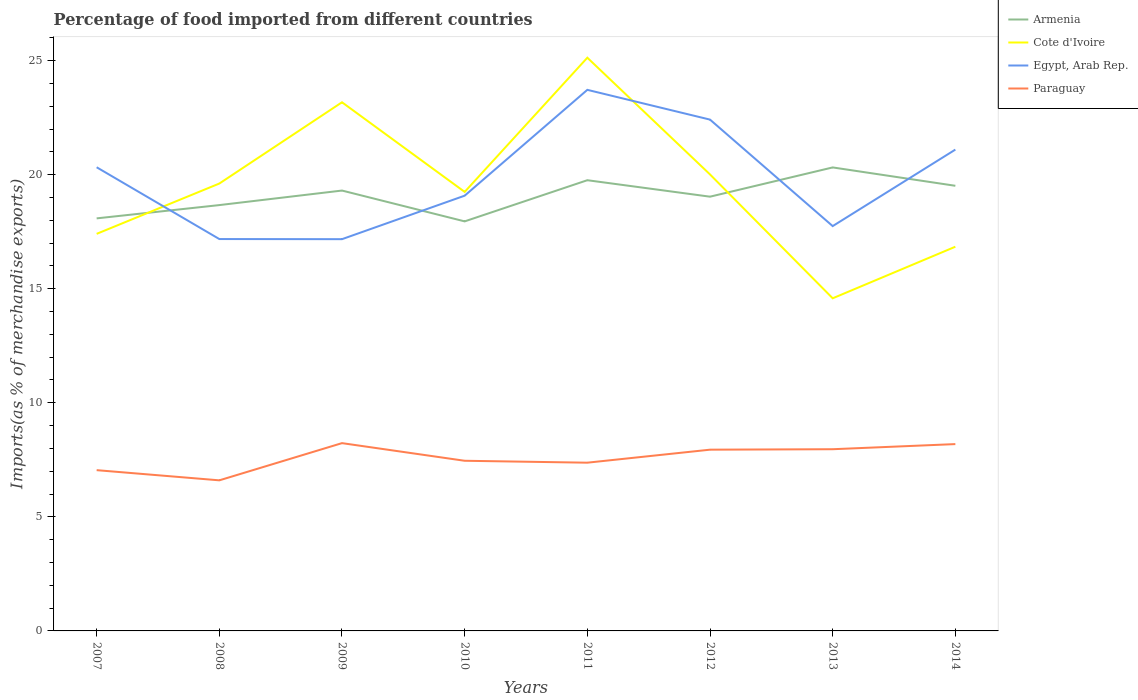Does the line corresponding to Paraguay intersect with the line corresponding to Egypt, Arab Rep.?
Your response must be concise. No. Is the number of lines equal to the number of legend labels?
Your answer should be compact. Yes. Across all years, what is the maximum percentage of imports to different countries in Cote d'Ivoire?
Your answer should be compact. 14.58. What is the total percentage of imports to different countries in Cote d'Ivoire in the graph?
Make the answer very short. 3.16. What is the difference between the highest and the second highest percentage of imports to different countries in Cote d'Ivoire?
Give a very brief answer. 10.55. How many years are there in the graph?
Your answer should be very brief. 8. Does the graph contain any zero values?
Ensure brevity in your answer.  No. Does the graph contain grids?
Provide a short and direct response. No. Where does the legend appear in the graph?
Your response must be concise. Top right. How are the legend labels stacked?
Offer a very short reply. Vertical. What is the title of the graph?
Ensure brevity in your answer.  Percentage of food imported from different countries. Does "Kosovo" appear as one of the legend labels in the graph?
Your answer should be very brief. No. What is the label or title of the X-axis?
Provide a succinct answer. Years. What is the label or title of the Y-axis?
Offer a very short reply. Imports(as % of merchandise exports). What is the Imports(as % of merchandise exports) in Armenia in 2007?
Your response must be concise. 18.08. What is the Imports(as % of merchandise exports) of Cote d'Ivoire in 2007?
Ensure brevity in your answer.  17.41. What is the Imports(as % of merchandise exports) in Egypt, Arab Rep. in 2007?
Your answer should be compact. 20.32. What is the Imports(as % of merchandise exports) of Paraguay in 2007?
Your answer should be compact. 7.05. What is the Imports(as % of merchandise exports) in Armenia in 2008?
Offer a very short reply. 18.67. What is the Imports(as % of merchandise exports) in Cote d'Ivoire in 2008?
Offer a very short reply. 19.61. What is the Imports(as % of merchandise exports) in Egypt, Arab Rep. in 2008?
Give a very brief answer. 17.18. What is the Imports(as % of merchandise exports) in Paraguay in 2008?
Your answer should be compact. 6.6. What is the Imports(as % of merchandise exports) of Armenia in 2009?
Give a very brief answer. 19.3. What is the Imports(as % of merchandise exports) in Cote d'Ivoire in 2009?
Provide a succinct answer. 23.17. What is the Imports(as % of merchandise exports) in Egypt, Arab Rep. in 2009?
Your answer should be compact. 17.17. What is the Imports(as % of merchandise exports) in Paraguay in 2009?
Ensure brevity in your answer.  8.23. What is the Imports(as % of merchandise exports) of Armenia in 2010?
Provide a short and direct response. 17.95. What is the Imports(as % of merchandise exports) in Cote d'Ivoire in 2010?
Ensure brevity in your answer.  19.24. What is the Imports(as % of merchandise exports) in Egypt, Arab Rep. in 2010?
Your answer should be very brief. 19.08. What is the Imports(as % of merchandise exports) in Paraguay in 2010?
Your answer should be compact. 7.46. What is the Imports(as % of merchandise exports) of Armenia in 2011?
Provide a short and direct response. 19.76. What is the Imports(as % of merchandise exports) of Cote d'Ivoire in 2011?
Provide a succinct answer. 25.13. What is the Imports(as % of merchandise exports) in Egypt, Arab Rep. in 2011?
Keep it short and to the point. 23.72. What is the Imports(as % of merchandise exports) of Paraguay in 2011?
Give a very brief answer. 7.37. What is the Imports(as % of merchandise exports) of Armenia in 2012?
Keep it short and to the point. 19.04. What is the Imports(as % of merchandise exports) in Cote d'Ivoire in 2012?
Provide a short and direct response. 20.01. What is the Imports(as % of merchandise exports) of Egypt, Arab Rep. in 2012?
Your answer should be compact. 22.41. What is the Imports(as % of merchandise exports) in Paraguay in 2012?
Offer a very short reply. 7.94. What is the Imports(as % of merchandise exports) of Armenia in 2013?
Your answer should be compact. 20.32. What is the Imports(as % of merchandise exports) in Cote d'Ivoire in 2013?
Provide a short and direct response. 14.58. What is the Imports(as % of merchandise exports) of Egypt, Arab Rep. in 2013?
Ensure brevity in your answer.  17.75. What is the Imports(as % of merchandise exports) in Paraguay in 2013?
Your response must be concise. 7.97. What is the Imports(as % of merchandise exports) of Armenia in 2014?
Your answer should be very brief. 19.51. What is the Imports(as % of merchandise exports) in Cote d'Ivoire in 2014?
Offer a terse response. 16.84. What is the Imports(as % of merchandise exports) in Egypt, Arab Rep. in 2014?
Ensure brevity in your answer.  21.1. What is the Imports(as % of merchandise exports) in Paraguay in 2014?
Provide a succinct answer. 8.19. Across all years, what is the maximum Imports(as % of merchandise exports) in Armenia?
Provide a short and direct response. 20.32. Across all years, what is the maximum Imports(as % of merchandise exports) of Cote d'Ivoire?
Give a very brief answer. 25.13. Across all years, what is the maximum Imports(as % of merchandise exports) of Egypt, Arab Rep.?
Offer a terse response. 23.72. Across all years, what is the maximum Imports(as % of merchandise exports) in Paraguay?
Give a very brief answer. 8.23. Across all years, what is the minimum Imports(as % of merchandise exports) of Armenia?
Offer a very short reply. 17.95. Across all years, what is the minimum Imports(as % of merchandise exports) in Cote d'Ivoire?
Give a very brief answer. 14.58. Across all years, what is the minimum Imports(as % of merchandise exports) of Egypt, Arab Rep.?
Provide a short and direct response. 17.17. Across all years, what is the minimum Imports(as % of merchandise exports) of Paraguay?
Provide a short and direct response. 6.6. What is the total Imports(as % of merchandise exports) of Armenia in the graph?
Provide a succinct answer. 152.63. What is the total Imports(as % of merchandise exports) in Cote d'Ivoire in the graph?
Your answer should be very brief. 156. What is the total Imports(as % of merchandise exports) in Egypt, Arab Rep. in the graph?
Offer a terse response. 158.73. What is the total Imports(as % of merchandise exports) of Paraguay in the graph?
Make the answer very short. 60.81. What is the difference between the Imports(as % of merchandise exports) in Armenia in 2007 and that in 2008?
Your response must be concise. -0.58. What is the difference between the Imports(as % of merchandise exports) of Cote d'Ivoire in 2007 and that in 2008?
Make the answer very short. -2.21. What is the difference between the Imports(as % of merchandise exports) of Egypt, Arab Rep. in 2007 and that in 2008?
Provide a succinct answer. 3.15. What is the difference between the Imports(as % of merchandise exports) in Paraguay in 2007 and that in 2008?
Offer a very short reply. 0.45. What is the difference between the Imports(as % of merchandise exports) in Armenia in 2007 and that in 2009?
Make the answer very short. -1.22. What is the difference between the Imports(as % of merchandise exports) of Cote d'Ivoire in 2007 and that in 2009?
Make the answer very short. -5.77. What is the difference between the Imports(as % of merchandise exports) of Egypt, Arab Rep. in 2007 and that in 2009?
Make the answer very short. 3.15. What is the difference between the Imports(as % of merchandise exports) in Paraguay in 2007 and that in 2009?
Provide a short and direct response. -1.18. What is the difference between the Imports(as % of merchandise exports) of Armenia in 2007 and that in 2010?
Keep it short and to the point. 0.13. What is the difference between the Imports(as % of merchandise exports) in Cote d'Ivoire in 2007 and that in 2010?
Offer a terse response. -1.84. What is the difference between the Imports(as % of merchandise exports) of Egypt, Arab Rep. in 2007 and that in 2010?
Make the answer very short. 1.25. What is the difference between the Imports(as % of merchandise exports) of Paraguay in 2007 and that in 2010?
Provide a succinct answer. -0.41. What is the difference between the Imports(as % of merchandise exports) of Armenia in 2007 and that in 2011?
Your response must be concise. -1.67. What is the difference between the Imports(as % of merchandise exports) in Cote d'Ivoire in 2007 and that in 2011?
Your response must be concise. -7.72. What is the difference between the Imports(as % of merchandise exports) of Egypt, Arab Rep. in 2007 and that in 2011?
Keep it short and to the point. -3.39. What is the difference between the Imports(as % of merchandise exports) of Paraguay in 2007 and that in 2011?
Give a very brief answer. -0.33. What is the difference between the Imports(as % of merchandise exports) in Armenia in 2007 and that in 2012?
Your response must be concise. -0.95. What is the difference between the Imports(as % of merchandise exports) of Cote d'Ivoire in 2007 and that in 2012?
Give a very brief answer. -2.6. What is the difference between the Imports(as % of merchandise exports) in Egypt, Arab Rep. in 2007 and that in 2012?
Provide a short and direct response. -2.09. What is the difference between the Imports(as % of merchandise exports) in Paraguay in 2007 and that in 2012?
Give a very brief answer. -0.9. What is the difference between the Imports(as % of merchandise exports) in Armenia in 2007 and that in 2013?
Your answer should be very brief. -2.23. What is the difference between the Imports(as % of merchandise exports) of Cote d'Ivoire in 2007 and that in 2013?
Your answer should be compact. 2.82. What is the difference between the Imports(as % of merchandise exports) in Egypt, Arab Rep. in 2007 and that in 2013?
Provide a short and direct response. 2.58. What is the difference between the Imports(as % of merchandise exports) of Paraguay in 2007 and that in 2013?
Offer a terse response. -0.92. What is the difference between the Imports(as % of merchandise exports) of Armenia in 2007 and that in 2014?
Your response must be concise. -1.43. What is the difference between the Imports(as % of merchandise exports) in Cote d'Ivoire in 2007 and that in 2014?
Your answer should be compact. 0.56. What is the difference between the Imports(as % of merchandise exports) of Egypt, Arab Rep. in 2007 and that in 2014?
Give a very brief answer. -0.77. What is the difference between the Imports(as % of merchandise exports) of Paraguay in 2007 and that in 2014?
Offer a very short reply. -1.14. What is the difference between the Imports(as % of merchandise exports) of Armenia in 2008 and that in 2009?
Offer a very short reply. -0.64. What is the difference between the Imports(as % of merchandise exports) of Cote d'Ivoire in 2008 and that in 2009?
Offer a very short reply. -3.56. What is the difference between the Imports(as % of merchandise exports) of Egypt, Arab Rep. in 2008 and that in 2009?
Offer a very short reply. 0.01. What is the difference between the Imports(as % of merchandise exports) in Paraguay in 2008 and that in 2009?
Make the answer very short. -1.63. What is the difference between the Imports(as % of merchandise exports) in Armenia in 2008 and that in 2010?
Keep it short and to the point. 0.71. What is the difference between the Imports(as % of merchandise exports) of Cote d'Ivoire in 2008 and that in 2010?
Offer a terse response. 0.37. What is the difference between the Imports(as % of merchandise exports) in Egypt, Arab Rep. in 2008 and that in 2010?
Provide a succinct answer. -1.9. What is the difference between the Imports(as % of merchandise exports) in Paraguay in 2008 and that in 2010?
Offer a terse response. -0.86. What is the difference between the Imports(as % of merchandise exports) of Armenia in 2008 and that in 2011?
Ensure brevity in your answer.  -1.09. What is the difference between the Imports(as % of merchandise exports) in Cote d'Ivoire in 2008 and that in 2011?
Your answer should be very brief. -5.52. What is the difference between the Imports(as % of merchandise exports) in Egypt, Arab Rep. in 2008 and that in 2011?
Provide a succinct answer. -6.54. What is the difference between the Imports(as % of merchandise exports) in Paraguay in 2008 and that in 2011?
Provide a succinct answer. -0.77. What is the difference between the Imports(as % of merchandise exports) in Armenia in 2008 and that in 2012?
Ensure brevity in your answer.  -0.37. What is the difference between the Imports(as % of merchandise exports) of Cote d'Ivoire in 2008 and that in 2012?
Offer a terse response. -0.4. What is the difference between the Imports(as % of merchandise exports) in Egypt, Arab Rep. in 2008 and that in 2012?
Make the answer very short. -5.24. What is the difference between the Imports(as % of merchandise exports) of Paraguay in 2008 and that in 2012?
Provide a succinct answer. -1.34. What is the difference between the Imports(as % of merchandise exports) of Armenia in 2008 and that in 2013?
Offer a terse response. -1.65. What is the difference between the Imports(as % of merchandise exports) of Cote d'Ivoire in 2008 and that in 2013?
Keep it short and to the point. 5.03. What is the difference between the Imports(as % of merchandise exports) in Egypt, Arab Rep. in 2008 and that in 2013?
Your answer should be compact. -0.57. What is the difference between the Imports(as % of merchandise exports) in Paraguay in 2008 and that in 2013?
Give a very brief answer. -1.36. What is the difference between the Imports(as % of merchandise exports) in Armenia in 2008 and that in 2014?
Keep it short and to the point. -0.85. What is the difference between the Imports(as % of merchandise exports) of Cote d'Ivoire in 2008 and that in 2014?
Ensure brevity in your answer.  2.77. What is the difference between the Imports(as % of merchandise exports) in Egypt, Arab Rep. in 2008 and that in 2014?
Make the answer very short. -3.92. What is the difference between the Imports(as % of merchandise exports) of Paraguay in 2008 and that in 2014?
Your answer should be very brief. -1.59. What is the difference between the Imports(as % of merchandise exports) of Armenia in 2009 and that in 2010?
Provide a succinct answer. 1.35. What is the difference between the Imports(as % of merchandise exports) of Cote d'Ivoire in 2009 and that in 2010?
Offer a terse response. 3.93. What is the difference between the Imports(as % of merchandise exports) in Egypt, Arab Rep. in 2009 and that in 2010?
Your answer should be very brief. -1.91. What is the difference between the Imports(as % of merchandise exports) in Paraguay in 2009 and that in 2010?
Your answer should be very brief. 0.77. What is the difference between the Imports(as % of merchandise exports) in Armenia in 2009 and that in 2011?
Your answer should be compact. -0.45. What is the difference between the Imports(as % of merchandise exports) in Cote d'Ivoire in 2009 and that in 2011?
Offer a very short reply. -1.95. What is the difference between the Imports(as % of merchandise exports) in Egypt, Arab Rep. in 2009 and that in 2011?
Give a very brief answer. -6.55. What is the difference between the Imports(as % of merchandise exports) of Paraguay in 2009 and that in 2011?
Keep it short and to the point. 0.86. What is the difference between the Imports(as % of merchandise exports) of Armenia in 2009 and that in 2012?
Your answer should be compact. 0.27. What is the difference between the Imports(as % of merchandise exports) in Cote d'Ivoire in 2009 and that in 2012?
Ensure brevity in your answer.  3.16. What is the difference between the Imports(as % of merchandise exports) of Egypt, Arab Rep. in 2009 and that in 2012?
Your response must be concise. -5.24. What is the difference between the Imports(as % of merchandise exports) in Paraguay in 2009 and that in 2012?
Give a very brief answer. 0.29. What is the difference between the Imports(as % of merchandise exports) in Armenia in 2009 and that in 2013?
Give a very brief answer. -1.01. What is the difference between the Imports(as % of merchandise exports) of Cote d'Ivoire in 2009 and that in 2013?
Your answer should be compact. 8.59. What is the difference between the Imports(as % of merchandise exports) of Egypt, Arab Rep. in 2009 and that in 2013?
Make the answer very short. -0.57. What is the difference between the Imports(as % of merchandise exports) in Paraguay in 2009 and that in 2013?
Provide a succinct answer. 0.27. What is the difference between the Imports(as % of merchandise exports) in Armenia in 2009 and that in 2014?
Keep it short and to the point. -0.21. What is the difference between the Imports(as % of merchandise exports) in Cote d'Ivoire in 2009 and that in 2014?
Provide a succinct answer. 6.33. What is the difference between the Imports(as % of merchandise exports) of Egypt, Arab Rep. in 2009 and that in 2014?
Provide a succinct answer. -3.93. What is the difference between the Imports(as % of merchandise exports) in Paraguay in 2009 and that in 2014?
Your answer should be very brief. 0.04. What is the difference between the Imports(as % of merchandise exports) in Armenia in 2010 and that in 2011?
Provide a short and direct response. -1.8. What is the difference between the Imports(as % of merchandise exports) in Cote d'Ivoire in 2010 and that in 2011?
Provide a short and direct response. -5.88. What is the difference between the Imports(as % of merchandise exports) in Egypt, Arab Rep. in 2010 and that in 2011?
Provide a succinct answer. -4.64. What is the difference between the Imports(as % of merchandise exports) in Paraguay in 2010 and that in 2011?
Make the answer very short. 0.08. What is the difference between the Imports(as % of merchandise exports) of Armenia in 2010 and that in 2012?
Provide a succinct answer. -1.08. What is the difference between the Imports(as % of merchandise exports) in Cote d'Ivoire in 2010 and that in 2012?
Your answer should be compact. -0.77. What is the difference between the Imports(as % of merchandise exports) in Egypt, Arab Rep. in 2010 and that in 2012?
Keep it short and to the point. -3.33. What is the difference between the Imports(as % of merchandise exports) in Paraguay in 2010 and that in 2012?
Make the answer very short. -0.49. What is the difference between the Imports(as % of merchandise exports) in Armenia in 2010 and that in 2013?
Ensure brevity in your answer.  -2.36. What is the difference between the Imports(as % of merchandise exports) in Cote d'Ivoire in 2010 and that in 2013?
Your response must be concise. 4.66. What is the difference between the Imports(as % of merchandise exports) of Egypt, Arab Rep. in 2010 and that in 2013?
Your answer should be compact. 1.33. What is the difference between the Imports(as % of merchandise exports) of Paraguay in 2010 and that in 2013?
Give a very brief answer. -0.51. What is the difference between the Imports(as % of merchandise exports) of Armenia in 2010 and that in 2014?
Provide a succinct answer. -1.56. What is the difference between the Imports(as % of merchandise exports) in Cote d'Ivoire in 2010 and that in 2014?
Keep it short and to the point. 2.4. What is the difference between the Imports(as % of merchandise exports) of Egypt, Arab Rep. in 2010 and that in 2014?
Give a very brief answer. -2.02. What is the difference between the Imports(as % of merchandise exports) of Paraguay in 2010 and that in 2014?
Provide a short and direct response. -0.73. What is the difference between the Imports(as % of merchandise exports) of Armenia in 2011 and that in 2012?
Your response must be concise. 0.72. What is the difference between the Imports(as % of merchandise exports) of Cote d'Ivoire in 2011 and that in 2012?
Offer a very short reply. 5.12. What is the difference between the Imports(as % of merchandise exports) of Egypt, Arab Rep. in 2011 and that in 2012?
Provide a short and direct response. 1.3. What is the difference between the Imports(as % of merchandise exports) of Paraguay in 2011 and that in 2012?
Keep it short and to the point. -0.57. What is the difference between the Imports(as % of merchandise exports) in Armenia in 2011 and that in 2013?
Offer a very short reply. -0.56. What is the difference between the Imports(as % of merchandise exports) in Cote d'Ivoire in 2011 and that in 2013?
Ensure brevity in your answer.  10.55. What is the difference between the Imports(as % of merchandise exports) in Egypt, Arab Rep. in 2011 and that in 2013?
Keep it short and to the point. 5.97. What is the difference between the Imports(as % of merchandise exports) of Paraguay in 2011 and that in 2013?
Give a very brief answer. -0.59. What is the difference between the Imports(as % of merchandise exports) of Armenia in 2011 and that in 2014?
Offer a very short reply. 0.24. What is the difference between the Imports(as % of merchandise exports) in Cote d'Ivoire in 2011 and that in 2014?
Provide a succinct answer. 8.29. What is the difference between the Imports(as % of merchandise exports) in Egypt, Arab Rep. in 2011 and that in 2014?
Your answer should be very brief. 2.62. What is the difference between the Imports(as % of merchandise exports) of Paraguay in 2011 and that in 2014?
Your answer should be very brief. -0.81. What is the difference between the Imports(as % of merchandise exports) in Armenia in 2012 and that in 2013?
Your answer should be compact. -1.28. What is the difference between the Imports(as % of merchandise exports) of Cote d'Ivoire in 2012 and that in 2013?
Keep it short and to the point. 5.43. What is the difference between the Imports(as % of merchandise exports) in Egypt, Arab Rep. in 2012 and that in 2013?
Your answer should be compact. 4.67. What is the difference between the Imports(as % of merchandise exports) in Paraguay in 2012 and that in 2013?
Your answer should be compact. -0.02. What is the difference between the Imports(as % of merchandise exports) of Armenia in 2012 and that in 2014?
Your answer should be very brief. -0.48. What is the difference between the Imports(as % of merchandise exports) of Cote d'Ivoire in 2012 and that in 2014?
Make the answer very short. 3.17. What is the difference between the Imports(as % of merchandise exports) in Egypt, Arab Rep. in 2012 and that in 2014?
Provide a short and direct response. 1.31. What is the difference between the Imports(as % of merchandise exports) of Paraguay in 2012 and that in 2014?
Offer a very short reply. -0.24. What is the difference between the Imports(as % of merchandise exports) in Armenia in 2013 and that in 2014?
Your response must be concise. 0.8. What is the difference between the Imports(as % of merchandise exports) of Cote d'Ivoire in 2013 and that in 2014?
Your answer should be compact. -2.26. What is the difference between the Imports(as % of merchandise exports) of Egypt, Arab Rep. in 2013 and that in 2014?
Provide a short and direct response. -3.35. What is the difference between the Imports(as % of merchandise exports) of Paraguay in 2013 and that in 2014?
Make the answer very short. -0.22. What is the difference between the Imports(as % of merchandise exports) in Armenia in 2007 and the Imports(as % of merchandise exports) in Cote d'Ivoire in 2008?
Offer a very short reply. -1.53. What is the difference between the Imports(as % of merchandise exports) of Armenia in 2007 and the Imports(as % of merchandise exports) of Egypt, Arab Rep. in 2008?
Offer a very short reply. 0.91. What is the difference between the Imports(as % of merchandise exports) of Armenia in 2007 and the Imports(as % of merchandise exports) of Paraguay in 2008?
Your answer should be compact. 11.48. What is the difference between the Imports(as % of merchandise exports) in Cote d'Ivoire in 2007 and the Imports(as % of merchandise exports) in Egypt, Arab Rep. in 2008?
Make the answer very short. 0.23. What is the difference between the Imports(as % of merchandise exports) of Cote d'Ivoire in 2007 and the Imports(as % of merchandise exports) of Paraguay in 2008?
Keep it short and to the point. 10.8. What is the difference between the Imports(as % of merchandise exports) of Egypt, Arab Rep. in 2007 and the Imports(as % of merchandise exports) of Paraguay in 2008?
Your answer should be compact. 13.72. What is the difference between the Imports(as % of merchandise exports) in Armenia in 2007 and the Imports(as % of merchandise exports) in Cote d'Ivoire in 2009?
Your response must be concise. -5.09. What is the difference between the Imports(as % of merchandise exports) in Armenia in 2007 and the Imports(as % of merchandise exports) in Egypt, Arab Rep. in 2009?
Provide a succinct answer. 0.91. What is the difference between the Imports(as % of merchandise exports) in Armenia in 2007 and the Imports(as % of merchandise exports) in Paraguay in 2009?
Provide a short and direct response. 9.85. What is the difference between the Imports(as % of merchandise exports) of Cote d'Ivoire in 2007 and the Imports(as % of merchandise exports) of Egypt, Arab Rep. in 2009?
Ensure brevity in your answer.  0.23. What is the difference between the Imports(as % of merchandise exports) of Cote d'Ivoire in 2007 and the Imports(as % of merchandise exports) of Paraguay in 2009?
Make the answer very short. 9.17. What is the difference between the Imports(as % of merchandise exports) in Egypt, Arab Rep. in 2007 and the Imports(as % of merchandise exports) in Paraguay in 2009?
Keep it short and to the point. 12.09. What is the difference between the Imports(as % of merchandise exports) of Armenia in 2007 and the Imports(as % of merchandise exports) of Cote d'Ivoire in 2010?
Provide a succinct answer. -1.16. What is the difference between the Imports(as % of merchandise exports) of Armenia in 2007 and the Imports(as % of merchandise exports) of Egypt, Arab Rep. in 2010?
Ensure brevity in your answer.  -0.99. What is the difference between the Imports(as % of merchandise exports) of Armenia in 2007 and the Imports(as % of merchandise exports) of Paraguay in 2010?
Offer a very short reply. 10.63. What is the difference between the Imports(as % of merchandise exports) of Cote d'Ivoire in 2007 and the Imports(as % of merchandise exports) of Egypt, Arab Rep. in 2010?
Provide a succinct answer. -1.67. What is the difference between the Imports(as % of merchandise exports) in Cote d'Ivoire in 2007 and the Imports(as % of merchandise exports) in Paraguay in 2010?
Give a very brief answer. 9.95. What is the difference between the Imports(as % of merchandise exports) of Egypt, Arab Rep. in 2007 and the Imports(as % of merchandise exports) of Paraguay in 2010?
Offer a very short reply. 12.87. What is the difference between the Imports(as % of merchandise exports) in Armenia in 2007 and the Imports(as % of merchandise exports) in Cote d'Ivoire in 2011?
Give a very brief answer. -7.04. What is the difference between the Imports(as % of merchandise exports) in Armenia in 2007 and the Imports(as % of merchandise exports) in Egypt, Arab Rep. in 2011?
Offer a very short reply. -5.63. What is the difference between the Imports(as % of merchandise exports) of Armenia in 2007 and the Imports(as % of merchandise exports) of Paraguay in 2011?
Offer a very short reply. 10.71. What is the difference between the Imports(as % of merchandise exports) of Cote d'Ivoire in 2007 and the Imports(as % of merchandise exports) of Egypt, Arab Rep. in 2011?
Your answer should be very brief. -6.31. What is the difference between the Imports(as % of merchandise exports) of Cote d'Ivoire in 2007 and the Imports(as % of merchandise exports) of Paraguay in 2011?
Your answer should be very brief. 10.03. What is the difference between the Imports(as % of merchandise exports) in Egypt, Arab Rep. in 2007 and the Imports(as % of merchandise exports) in Paraguay in 2011?
Your response must be concise. 12.95. What is the difference between the Imports(as % of merchandise exports) in Armenia in 2007 and the Imports(as % of merchandise exports) in Cote d'Ivoire in 2012?
Provide a succinct answer. -1.93. What is the difference between the Imports(as % of merchandise exports) in Armenia in 2007 and the Imports(as % of merchandise exports) in Egypt, Arab Rep. in 2012?
Give a very brief answer. -4.33. What is the difference between the Imports(as % of merchandise exports) in Armenia in 2007 and the Imports(as % of merchandise exports) in Paraguay in 2012?
Your answer should be very brief. 10.14. What is the difference between the Imports(as % of merchandise exports) of Cote d'Ivoire in 2007 and the Imports(as % of merchandise exports) of Egypt, Arab Rep. in 2012?
Your answer should be compact. -5.01. What is the difference between the Imports(as % of merchandise exports) in Cote d'Ivoire in 2007 and the Imports(as % of merchandise exports) in Paraguay in 2012?
Give a very brief answer. 9.46. What is the difference between the Imports(as % of merchandise exports) of Egypt, Arab Rep. in 2007 and the Imports(as % of merchandise exports) of Paraguay in 2012?
Provide a succinct answer. 12.38. What is the difference between the Imports(as % of merchandise exports) of Armenia in 2007 and the Imports(as % of merchandise exports) of Cote d'Ivoire in 2013?
Offer a very short reply. 3.5. What is the difference between the Imports(as % of merchandise exports) in Armenia in 2007 and the Imports(as % of merchandise exports) in Egypt, Arab Rep. in 2013?
Offer a very short reply. 0.34. What is the difference between the Imports(as % of merchandise exports) in Armenia in 2007 and the Imports(as % of merchandise exports) in Paraguay in 2013?
Offer a very short reply. 10.12. What is the difference between the Imports(as % of merchandise exports) of Cote d'Ivoire in 2007 and the Imports(as % of merchandise exports) of Egypt, Arab Rep. in 2013?
Your answer should be very brief. -0.34. What is the difference between the Imports(as % of merchandise exports) of Cote d'Ivoire in 2007 and the Imports(as % of merchandise exports) of Paraguay in 2013?
Keep it short and to the point. 9.44. What is the difference between the Imports(as % of merchandise exports) in Egypt, Arab Rep. in 2007 and the Imports(as % of merchandise exports) in Paraguay in 2013?
Give a very brief answer. 12.36. What is the difference between the Imports(as % of merchandise exports) of Armenia in 2007 and the Imports(as % of merchandise exports) of Cote d'Ivoire in 2014?
Provide a succinct answer. 1.24. What is the difference between the Imports(as % of merchandise exports) in Armenia in 2007 and the Imports(as % of merchandise exports) in Egypt, Arab Rep. in 2014?
Offer a very short reply. -3.01. What is the difference between the Imports(as % of merchandise exports) of Armenia in 2007 and the Imports(as % of merchandise exports) of Paraguay in 2014?
Your response must be concise. 9.89. What is the difference between the Imports(as % of merchandise exports) of Cote d'Ivoire in 2007 and the Imports(as % of merchandise exports) of Egypt, Arab Rep. in 2014?
Your response must be concise. -3.69. What is the difference between the Imports(as % of merchandise exports) of Cote d'Ivoire in 2007 and the Imports(as % of merchandise exports) of Paraguay in 2014?
Offer a very short reply. 9.22. What is the difference between the Imports(as % of merchandise exports) of Egypt, Arab Rep. in 2007 and the Imports(as % of merchandise exports) of Paraguay in 2014?
Ensure brevity in your answer.  12.14. What is the difference between the Imports(as % of merchandise exports) of Armenia in 2008 and the Imports(as % of merchandise exports) of Cote d'Ivoire in 2009?
Provide a succinct answer. -4.51. What is the difference between the Imports(as % of merchandise exports) of Armenia in 2008 and the Imports(as % of merchandise exports) of Egypt, Arab Rep. in 2009?
Make the answer very short. 1.49. What is the difference between the Imports(as % of merchandise exports) in Armenia in 2008 and the Imports(as % of merchandise exports) in Paraguay in 2009?
Your answer should be very brief. 10.43. What is the difference between the Imports(as % of merchandise exports) of Cote d'Ivoire in 2008 and the Imports(as % of merchandise exports) of Egypt, Arab Rep. in 2009?
Provide a succinct answer. 2.44. What is the difference between the Imports(as % of merchandise exports) in Cote d'Ivoire in 2008 and the Imports(as % of merchandise exports) in Paraguay in 2009?
Your answer should be very brief. 11.38. What is the difference between the Imports(as % of merchandise exports) in Egypt, Arab Rep. in 2008 and the Imports(as % of merchandise exports) in Paraguay in 2009?
Your answer should be very brief. 8.95. What is the difference between the Imports(as % of merchandise exports) of Armenia in 2008 and the Imports(as % of merchandise exports) of Cote d'Ivoire in 2010?
Offer a very short reply. -0.58. What is the difference between the Imports(as % of merchandise exports) of Armenia in 2008 and the Imports(as % of merchandise exports) of Egypt, Arab Rep. in 2010?
Ensure brevity in your answer.  -0.41. What is the difference between the Imports(as % of merchandise exports) of Armenia in 2008 and the Imports(as % of merchandise exports) of Paraguay in 2010?
Provide a short and direct response. 11.21. What is the difference between the Imports(as % of merchandise exports) of Cote d'Ivoire in 2008 and the Imports(as % of merchandise exports) of Egypt, Arab Rep. in 2010?
Ensure brevity in your answer.  0.53. What is the difference between the Imports(as % of merchandise exports) of Cote d'Ivoire in 2008 and the Imports(as % of merchandise exports) of Paraguay in 2010?
Your answer should be very brief. 12.15. What is the difference between the Imports(as % of merchandise exports) of Egypt, Arab Rep. in 2008 and the Imports(as % of merchandise exports) of Paraguay in 2010?
Offer a terse response. 9.72. What is the difference between the Imports(as % of merchandise exports) in Armenia in 2008 and the Imports(as % of merchandise exports) in Cote d'Ivoire in 2011?
Ensure brevity in your answer.  -6.46. What is the difference between the Imports(as % of merchandise exports) of Armenia in 2008 and the Imports(as % of merchandise exports) of Egypt, Arab Rep. in 2011?
Make the answer very short. -5.05. What is the difference between the Imports(as % of merchandise exports) in Armenia in 2008 and the Imports(as % of merchandise exports) in Paraguay in 2011?
Offer a very short reply. 11.29. What is the difference between the Imports(as % of merchandise exports) of Cote d'Ivoire in 2008 and the Imports(as % of merchandise exports) of Egypt, Arab Rep. in 2011?
Offer a terse response. -4.11. What is the difference between the Imports(as % of merchandise exports) of Cote d'Ivoire in 2008 and the Imports(as % of merchandise exports) of Paraguay in 2011?
Your response must be concise. 12.24. What is the difference between the Imports(as % of merchandise exports) of Egypt, Arab Rep. in 2008 and the Imports(as % of merchandise exports) of Paraguay in 2011?
Ensure brevity in your answer.  9.8. What is the difference between the Imports(as % of merchandise exports) of Armenia in 2008 and the Imports(as % of merchandise exports) of Cote d'Ivoire in 2012?
Offer a terse response. -1.34. What is the difference between the Imports(as % of merchandise exports) of Armenia in 2008 and the Imports(as % of merchandise exports) of Egypt, Arab Rep. in 2012?
Keep it short and to the point. -3.75. What is the difference between the Imports(as % of merchandise exports) of Armenia in 2008 and the Imports(as % of merchandise exports) of Paraguay in 2012?
Keep it short and to the point. 10.72. What is the difference between the Imports(as % of merchandise exports) of Cote d'Ivoire in 2008 and the Imports(as % of merchandise exports) of Egypt, Arab Rep. in 2012?
Provide a succinct answer. -2.8. What is the difference between the Imports(as % of merchandise exports) of Cote d'Ivoire in 2008 and the Imports(as % of merchandise exports) of Paraguay in 2012?
Give a very brief answer. 11.67. What is the difference between the Imports(as % of merchandise exports) of Egypt, Arab Rep. in 2008 and the Imports(as % of merchandise exports) of Paraguay in 2012?
Provide a short and direct response. 9.23. What is the difference between the Imports(as % of merchandise exports) in Armenia in 2008 and the Imports(as % of merchandise exports) in Cote d'Ivoire in 2013?
Keep it short and to the point. 4.09. What is the difference between the Imports(as % of merchandise exports) of Armenia in 2008 and the Imports(as % of merchandise exports) of Egypt, Arab Rep. in 2013?
Your answer should be compact. 0.92. What is the difference between the Imports(as % of merchandise exports) in Armenia in 2008 and the Imports(as % of merchandise exports) in Paraguay in 2013?
Your answer should be very brief. 10.7. What is the difference between the Imports(as % of merchandise exports) of Cote d'Ivoire in 2008 and the Imports(as % of merchandise exports) of Egypt, Arab Rep. in 2013?
Keep it short and to the point. 1.87. What is the difference between the Imports(as % of merchandise exports) in Cote d'Ivoire in 2008 and the Imports(as % of merchandise exports) in Paraguay in 2013?
Give a very brief answer. 11.65. What is the difference between the Imports(as % of merchandise exports) of Egypt, Arab Rep. in 2008 and the Imports(as % of merchandise exports) of Paraguay in 2013?
Your response must be concise. 9.21. What is the difference between the Imports(as % of merchandise exports) of Armenia in 2008 and the Imports(as % of merchandise exports) of Cote d'Ivoire in 2014?
Make the answer very short. 1.82. What is the difference between the Imports(as % of merchandise exports) of Armenia in 2008 and the Imports(as % of merchandise exports) of Egypt, Arab Rep. in 2014?
Give a very brief answer. -2.43. What is the difference between the Imports(as % of merchandise exports) of Armenia in 2008 and the Imports(as % of merchandise exports) of Paraguay in 2014?
Offer a very short reply. 10.48. What is the difference between the Imports(as % of merchandise exports) of Cote d'Ivoire in 2008 and the Imports(as % of merchandise exports) of Egypt, Arab Rep. in 2014?
Make the answer very short. -1.49. What is the difference between the Imports(as % of merchandise exports) in Cote d'Ivoire in 2008 and the Imports(as % of merchandise exports) in Paraguay in 2014?
Provide a succinct answer. 11.42. What is the difference between the Imports(as % of merchandise exports) in Egypt, Arab Rep. in 2008 and the Imports(as % of merchandise exports) in Paraguay in 2014?
Ensure brevity in your answer.  8.99. What is the difference between the Imports(as % of merchandise exports) in Armenia in 2009 and the Imports(as % of merchandise exports) in Cote d'Ivoire in 2010?
Ensure brevity in your answer.  0.06. What is the difference between the Imports(as % of merchandise exports) in Armenia in 2009 and the Imports(as % of merchandise exports) in Egypt, Arab Rep. in 2010?
Give a very brief answer. 0.22. What is the difference between the Imports(as % of merchandise exports) in Armenia in 2009 and the Imports(as % of merchandise exports) in Paraguay in 2010?
Your response must be concise. 11.85. What is the difference between the Imports(as % of merchandise exports) of Cote d'Ivoire in 2009 and the Imports(as % of merchandise exports) of Egypt, Arab Rep. in 2010?
Your answer should be compact. 4.09. What is the difference between the Imports(as % of merchandise exports) of Cote d'Ivoire in 2009 and the Imports(as % of merchandise exports) of Paraguay in 2010?
Keep it short and to the point. 15.72. What is the difference between the Imports(as % of merchandise exports) in Egypt, Arab Rep. in 2009 and the Imports(as % of merchandise exports) in Paraguay in 2010?
Make the answer very short. 9.71. What is the difference between the Imports(as % of merchandise exports) in Armenia in 2009 and the Imports(as % of merchandise exports) in Cote d'Ivoire in 2011?
Provide a short and direct response. -5.82. What is the difference between the Imports(as % of merchandise exports) of Armenia in 2009 and the Imports(as % of merchandise exports) of Egypt, Arab Rep. in 2011?
Make the answer very short. -4.41. What is the difference between the Imports(as % of merchandise exports) in Armenia in 2009 and the Imports(as % of merchandise exports) in Paraguay in 2011?
Provide a short and direct response. 11.93. What is the difference between the Imports(as % of merchandise exports) of Cote d'Ivoire in 2009 and the Imports(as % of merchandise exports) of Egypt, Arab Rep. in 2011?
Provide a short and direct response. -0.54. What is the difference between the Imports(as % of merchandise exports) of Cote d'Ivoire in 2009 and the Imports(as % of merchandise exports) of Paraguay in 2011?
Ensure brevity in your answer.  15.8. What is the difference between the Imports(as % of merchandise exports) of Egypt, Arab Rep. in 2009 and the Imports(as % of merchandise exports) of Paraguay in 2011?
Give a very brief answer. 9.8. What is the difference between the Imports(as % of merchandise exports) in Armenia in 2009 and the Imports(as % of merchandise exports) in Cote d'Ivoire in 2012?
Keep it short and to the point. -0.71. What is the difference between the Imports(as % of merchandise exports) of Armenia in 2009 and the Imports(as % of merchandise exports) of Egypt, Arab Rep. in 2012?
Offer a very short reply. -3.11. What is the difference between the Imports(as % of merchandise exports) in Armenia in 2009 and the Imports(as % of merchandise exports) in Paraguay in 2012?
Your answer should be very brief. 11.36. What is the difference between the Imports(as % of merchandise exports) in Cote d'Ivoire in 2009 and the Imports(as % of merchandise exports) in Egypt, Arab Rep. in 2012?
Ensure brevity in your answer.  0.76. What is the difference between the Imports(as % of merchandise exports) of Cote d'Ivoire in 2009 and the Imports(as % of merchandise exports) of Paraguay in 2012?
Make the answer very short. 15.23. What is the difference between the Imports(as % of merchandise exports) in Egypt, Arab Rep. in 2009 and the Imports(as % of merchandise exports) in Paraguay in 2012?
Your answer should be compact. 9.23. What is the difference between the Imports(as % of merchandise exports) of Armenia in 2009 and the Imports(as % of merchandise exports) of Cote d'Ivoire in 2013?
Ensure brevity in your answer.  4.72. What is the difference between the Imports(as % of merchandise exports) in Armenia in 2009 and the Imports(as % of merchandise exports) in Egypt, Arab Rep. in 2013?
Keep it short and to the point. 1.56. What is the difference between the Imports(as % of merchandise exports) of Armenia in 2009 and the Imports(as % of merchandise exports) of Paraguay in 2013?
Provide a short and direct response. 11.34. What is the difference between the Imports(as % of merchandise exports) of Cote d'Ivoire in 2009 and the Imports(as % of merchandise exports) of Egypt, Arab Rep. in 2013?
Keep it short and to the point. 5.43. What is the difference between the Imports(as % of merchandise exports) of Cote d'Ivoire in 2009 and the Imports(as % of merchandise exports) of Paraguay in 2013?
Ensure brevity in your answer.  15.21. What is the difference between the Imports(as % of merchandise exports) in Egypt, Arab Rep. in 2009 and the Imports(as % of merchandise exports) in Paraguay in 2013?
Your answer should be very brief. 9.21. What is the difference between the Imports(as % of merchandise exports) of Armenia in 2009 and the Imports(as % of merchandise exports) of Cote d'Ivoire in 2014?
Your answer should be very brief. 2.46. What is the difference between the Imports(as % of merchandise exports) in Armenia in 2009 and the Imports(as % of merchandise exports) in Egypt, Arab Rep. in 2014?
Offer a terse response. -1.8. What is the difference between the Imports(as % of merchandise exports) of Armenia in 2009 and the Imports(as % of merchandise exports) of Paraguay in 2014?
Your response must be concise. 11.11. What is the difference between the Imports(as % of merchandise exports) in Cote d'Ivoire in 2009 and the Imports(as % of merchandise exports) in Egypt, Arab Rep. in 2014?
Provide a short and direct response. 2.07. What is the difference between the Imports(as % of merchandise exports) of Cote d'Ivoire in 2009 and the Imports(as % of merchandise exports) of Paraguay in 2014?
Your answer should be very brief. 14.98. What is the difference between the Imports(as % of merchandise exports) in Egypt, Arab Rep. in 2009 and the Imports(as % of merchandise exports) in Paraguay in 2014?
Make the answer very short. 8.98. What is the difference between the Imports(as % of merchandise exports) of Armenia in 2010 and the Imports(as % of merchandise exports) of Cote d'Ivoire in 2011?
Give a very brief answer. -7.17. What is the difference between the Imports(as % of merchandise exports) in Armenia in 2010 and the Imports(as % of merchandise exports) in Egypt, Arab Rep. in 2011?
Provide a short and direct response. -5.77. What is the difference between the Imports(as % of merchandise exports) of Armenia in 2010 and the Imports(as % of merchandise exports) of Paraguay in 2011?
Provide a short and direct response. 10.58. What is the difference between the Imports(as % of merchandise exports) in Cote d'Ivoire in 2010 and the Imports(as % of merchandise exports) in Egypt, Arab Rep. in 2011?
Your response must be concise. -4.47. What is the difference between the Imports(as % of merchandise exports) of Cote d'Ivoire in 2010 and the Imports(as % of merchandise exports) of Paraguay in 2011?
Your answer should be compact. 11.87. What is the difference between the Imports(as % of merchandise exports) in Egypt, Arab Rep. in 2010 and the Imports(as % of merchandise exports) in Paraguay in 2011?
Your answer should be very brief. 11.7. What is the difference between the Imports(as % of merchandise exports) in Armenia in 2010 and the Imports(as % of merchandise exports) in Cote d'Ivoire in 2012?
Give a very brief answer. -2.06. What is the difference between the Imports(as % of merchandise exports) in Armenia in 2010 and the Imports(as % of merchandise exports) in Egypt, Arab Rep. in 2012?
Offer a terse response. -4.46. What is the difference between the Imports(as % of merchandise exports) in Armenia in 2010 and the Imports(as % of merchandise exports) in Paraguay in 2012?
Keep it short and to the point. 10.01. What is the difference between the Imports(as % of merchandise exports) in Cote d'Ivoire in 2010 and the Imports(as % of merchandise exports) in Egypt, Arab Rep. in 2012?
Offer a terse response. -3.17. What is the difference between the Imports(as % of merchandise exports) in Cote d'Ivoire in 2010 and the Imports(as % of merchandise exports) in Paraguay in 2012?
Give a very brief answer. 11.3. What is the difference between the Imports(as % of merchandise exports) of Egypt, Arab Rep. in 2010 and the Imports(as % of merchandise exports) of Paraguay in 2012?
Your response must be concise. 11.13. What is the difference between the Imports(as % of merchandise exports) in Armenia in 2010 and the Imports(as % of merchandise exports) in Cote d'Ivoire in 2013?
Provide a succinct answer. 3.37. What is the difference between the Imports(as % of merchandise exports) of Armenia in 2010 and the Imports(as % of merchandise exports) of Egypt, Arab Rep. in 2013?
Make the answer very short. 0.21. What is the difference between the Imports(as % of merchandise exports) in Armenia in 2010 and the Imports(as % of merchandise exports) in Paraguay in 2013?
Keep it short and to the point. 9.99. What is the difference between the Imports(as % of merchandise exports) of Cote d'Ivoire in 2010 and the Imports(as % of merchandise exports) of Egypt, Arab Rep. in 2013?
Ensure brevity in your answer.  1.5. What is the difference between the Imports(as % of merchandise exports) in Cote d'Ivoire in 2010 and the Imports(as % of merchandise exports) in Paraguay in 2013?
Your answer should be compact. 11.28. What is the difference between the Imports(as % of merchandise exports) of Egypt, Arab Rep. in 2010 and the Imports(as % of merchandise exports) of Paraguay in 2013?
Give a very brief answer. 11.11. What is the difference between the Imports(as % of merchandise exports) in Armenia in 2010 and the Imports(as % of merchandise exports) in Cote d'Ivoire in 2014?
Provide a short and direct response. 1.11. What is the difference between the Imports(as % of merchandise exports) of Armenia in 2010 and the Imports(as % of merchandise exports) of Egypt, Arab Rep. in 2014?
Your response must be concise. -3.15. What is the difference between the Imports(as % of merchandise exports) in Armenia in 2010 and the Imports(as % of merchandise exports) in Paraguay in 2014?
Make the answer very short. 9.76. What is the difference between the Imports(as % of merchandise exports) of Cote d'Ivoire in 2010 and the Imports(as % of merchandise exports) of Egypt, Arab Rep. in 2014?
Ensure brevity in your answer.  -1.85. What is the difference between the Imports(as % of merchandise exports) in Cote d'Ivoire in 2010 and the Imports(as % of merchandise exports) in Paraguay in 2014?
Give a very brief answer. 11.06. What is the difference between the Imports(as % of merchandise exports) in Egypt, Arab Rep. in 2010 and the Imports(as % of merchandise exports) in Paraguay in 2014?
Your answer should be compact. 10.89. What is the difference between the Imports(as % of merchandise exports) of Armenia in 2011 and the Imports(as % of merchandise exports) of Cote d'Ivoire in 2012?
Your answer should be compact. -0.25. What is the difference between the Imports(as % of merchandise exports) in Armenia in 2011 and the Imports(as % of merchandise exports) in Egypt, Arab Rep. in 2012?
Offer a terse response. -2.66. What is the difference between the Imports(as % of merchandise exports) of Armenia in 2011 and the Imports(as % of merchandise exports) of Paraguay in 2012?
Give a very brief answer. 11.81. What is the difference between the Imports(as % of merchandise exports) of Cote d'Ivoire in 2011 and the Imports(as % of merchandise exports) of Egypt, Arab Rep. in 2012?
Your answer should be very brief. 2.71. What is the difference between the Imports(as % of merchandise exports) of Cote d'Ivoire in 2011 and the Imports(as % of merchandise exports) of Paraguay in 2012?
Your answer should be very brief. 17.18. What is the difference between the Imports(as % of merchandise exports) in Egypt, Arab Rep. in 2011 and the Imports(as % of merchandise exports) in Paraguay in 2012?
Provide a succinct answer. 15.77. What is the difference between the Imports(as % of merchandise exports) in Armenia in 2011 and the Imports(as % of merchandise exports) in Cote d'Ivoire in 2013?
Your answer should be compact. 5.18. What is the difference between the Imports(as % of merchandise exports) of Armenia in 2011 and the Imports(as % of merchandise exports) of Egypt, Arab Rep. in 2013?
Offer a very short reply. 2.01. What is the difference between the Imports(as % of merchandise exports) in Armenia in 2011 and the Imports(as % of merchandise exports) in Paraguay in 2013?
Give a very brief answer. 11.79. What is the difference between the Imports(as % of merchandise exports) in Cote d'Ivoire in 2011 and the Imports(as % of merchandise exports) in Egypt, Arab Rep. in 2013?
Keep it short and to the point. 7.38. What is the difference between the Imports(as % of merchandise exports) of Cote d'Ivoire in 2011 and the Imports(as % of merchandise exports) of Paraguay in 2013?
Your answer should be very brief. 17.16. What is the difference between the Imports(as % of merchandise exports) of Egypt, Arab Rep. in 2011 and the Imports(as % of merchandise exports) of Paraguay in 2013?
Provide a succinct answer. 15.75. What is the difference between the Imports(as % of merchandise exports) in Armenia in 2011 and the Imports(as % of merchandise exports) in Cote d'Ivoire in 2014?
Provide a succinct answer. 2.92. What is the difference between the Imports(as % of merchandise exports) of Armenia in 2011 and the Imports(as % of merchandise exports) of Egypt, Arab Rep. in 2014?
Ensure brevity in your answer.  -1.34. What is the difference between the Imports(as % of merchandise exports) of Armenia in 2011 and the Imports(as % of merchandise exports) of Paraguay in 2014?
Your answer should be very brief. 11.57. What is the difference between the Imports(as % of merchandise exports) of Cote d'Ivoire in 2011 and the Imports(as % of merchandise exports) of Egypt, Arab Rep. in 2014?
Provide a short and direct response. 4.03. What is the difference between the Imports(as % of merchandise exports) of Cote d'Ivoire in 2011 and the Imports(as % of merchandise exports) of Paraguay in 2014?
Give a very brief answer. 16.94. What is the difference between the Imports(as % of merchandise exports) in Egypt, Arab Rep. in 2011 and the Imports(as % of merchandise exports) in Paraguay in 2014?
Your response must be concise. 15.53. What is the difference between the Imports(as % of merchandise exports) of Armenia in 2012 and the Imports(as % of merchandise exports) of Cote d'Ivoire in 2013?
Your answer should be compact. 4.45. What is the difference between the Imports(as % of merchandise exports) in Armenia in 2012 and the Imports(as % of merchandise exports) in Egypt, Arab Rep. in 2013?
Give a very brief answer. 1.29. What is the difference between the Imports(as % of merchandise exports) of Armenia in 2012 and the Imports(as % of merchandise exports) of Paraguay in 2013?
Make the answer very short. 11.07. What is the difference between the Imports(as % of merchandise exports) in Cote d'Ivoire in 2012 and the Imports(as % of merchandise exports) in Egypt, Arab Rep. in 2013?
Your response must be concise. 2.27. What is the difference between the Imports(as % of merchandise exports) of Cote d'Ivoire in 2012 and the Imports(as % of merchandise exports) of Paraguay in 2013?
Your answer should be compact. 12.05. What is the difference between the Imports(as % of merchandise exports) of Egypt, Arab Rep. in 2012 and the Imports(as % of merchandise exports) of Paraguay in 2013?
Make the answer very short. 14.45. What is the difference between the Imports(as % of merchandise exports) in Armenia in 2012 and the Imports(as % of merchandise exports) in Cote d'Ivoire in 2014?
Keep it short and to the point. 2.19. What is the difference between the Imports(as % of merchandise exports) in Armenia in 2012 and the Imports(as % of merchandise exports) in Egypt, Arab Rep. in 2014?
Your answer should be very brief. -2.06. What is the difference between the Imports(as % of merchandise exports) of Armenia in 2012 and the Imports(as % of merchandise exports) of Paraguay in 2014?
Ensure brevity in your answer.  10.85. What is the difference between the Imports(as % of merchandise exports) in Cote d'Ivoire in 2012 and the Imports(as % of merchandise exports) in Egypt, Arab Rep. in 2014?
Offer a very short reply. -1.09. What is the difference between the Imports(as % of merchandise exports) in Cote d'Ivoire in 2012 and the Imports(as % of merchandise exports) in Paraguay in 2014?
Your answer should be compact. 11.82. What is the difference between the Imports(as % of merchandise exports) in Egypt, Arab Rep. in 2012 and the Imports(as % of merchandise exports) in Paraguay in 2014?
Provide a succinct answer. 14.22. What is the difference between the Imports(as % of merchandise exports) of Armenia in 2013 and the Imports(as % of merchandise exports) of Cote d'Ivoire in 2014?
Your answer should be very brief. 3.48. What is the difference between the Imports(as % of merchandise exports) in Armenia in 2013 and the Imports(as % of merchandise exports) in Egypt, Arab Rep. in 2014?
Offer a very short reply. -0.78. What is the difference between the Imports(as % of merchandise exports) in Armenia in 2013 and the Imports(as % of merchandise exports) in Paraguay in 2014?
Keep it short and to the point. 12.13. What is the difference between the Imports(as % of merchandise exports) in Cote d'Ivoire in 2013 and the Imports(as % of merchandise exports) in Egypt, Arab Rep. in 2014?
Offer a terse response. -6.52. What is the difference between the Imports(as % of merchandise exports) in Cote d'Ivoire in 2013 and the Imports(as % of merchandise exports) in Paraguay in 2014?
Your answer should be compact. 6.39. What is the difference between the Imports(as % of merchandise exports) of Egypt, Arab Rep. in 2013 and the Imports(as % of merchandise exports) of Paraguay in 2014?
Ensure brevity in your answer.  9.56. What is the average Imports(as % of merchandise exports) of Armenia per year?
Offer a terse response. 19.08. What is the average Imports(as % of merchandise exports) of Cote d'Ivoire per year?
Give a very brief answer. 19.5. What is the average Imports(as % of merchandise exports) of Egypt, Arab Rep. per year?
Your answer should be very brief. 19.84. What is the average Imports(as % of merchandise exports) of Paraguay per year?
Keep it short and to the point. 7.6. In the year 2007, what is the difference between the Imports(as % of merchandise exports) of Armenia and Imports(as % of merchandise exports) of Cote d'Ivoire?
Provide a short and direct response. 0.68. In the year 2007, what is the difference between the Imports(as % of merchandise exports) in Armenia and Imports(as % of merchandise exports) in Egypt, Arab Rep.?
Your response must be concise. -2.24. In the year 2007, what is the difference between the Imports(as % of merchandise exports) of Armenia and Imports(as % of merchandise exports) of Paraguay?
Your response must be concise. 11.04. In the year 2007, what is the difference between the Imports(as % of merchandise exports) in Cote d'Ivoire and Imports(as % of merchandise exports) in Egypt, Arab Rep.?
Your response must be concise. -2.92. In the year 2007, what is the difference between the Imports(as % of merchandise exports) in Cote d'Ivoire and Imports(as % of merchandise exports) in Paraguay?
Your answer should be compact. 10.36. In the year 2007, what is the difference between the Imports(as % of merchandise exports) in Egypt, Arab Rep. and Imports(as % of merchandise exports) in Paraguay?
Provide a short and direct response. 13.28. In the year 2008, what is the difference between the Imports(as % of merchandise exports) of Armenia and Imports(as % of merchandise exports) of Cote d'Ivoire?
Your answer should be very brief. -0.94. In the year 2008, what is the difference between the Imports(as % of merchandise exports) in Armenia and Imports(as % of merchandise exports) in Egypt, Arab Rep.?
Ensure brevity in your answer.  1.49. In the year 2008, what is the difference between the Imports(as % of merchandise exports) in Armenia and Imports(as % of merchandise exports) in Paraguay?
Offer a terse response. 12.07. In the year 2008, what is the difference between the Imports(as % of merchandise exports) in Cote d'Ivoire and Imports(as % of merchandise exports) in Egypt, Arab Rep.?
Offer a terse response. 2.43. In the year 2008, what is the difference between the Imports(as % of merchandise exports) of Cote d'Ivoire and Imports(as % of merchandise exports) of Paraguay?
Make the answer very short. 13.01. In the year 2008, what is the difference between the Imports(as % of merchandise exports) of Egypt, Arab Rep. and Imports(as % of merchandise exports) of Paraguay?
Provide a succinct answer. 10.58. In the year 2009, what is the difference between the Imports(as % of merchandise exports) of Armenia and Imports(as % of merchandise exports) of Cote d'Ivoire?
Give a very brief answer. -3.87. In the year 2009, what is the difference between the Imports(as % of merchandise exports) in Armenia and Imports(as % of merchandise exports) in Egypt, Arab Rep.?
Give a very brief answer. 2.13. In the year 2009, what is the difference between the Imports(as % of merchandise exports) in Armenia and Imports(as % of merchandise exports) in Paraguay?
Offer a terse response. 11.07. In the year 2009, what is the difference between the Imports(as % of merchandise exports) of Cote d'Ivoire and Imports(as % of merchandise exports) of Egypt, Arab Rep.?
Keep it short and to the point. 6. In the year 2009, what is the difference between the Imports(as % of merchandise exports) in Cote d'Ivoire and Imports(as % of merchandise exports) in Paraguay?
Provide a short and direct response. 14.94. In the year 2009, what is the difference between the Imports(as % of merchandise exports) of Egypt, Arab Rep. and Imports(as % of merchandise exports) of Paraguay?
Provide a short and direct response. 8.94. In the year 2010, what is the difference between the Imports(as % of merchandise exports) in Armenia and Imports(as % of merchandise exports) in Cote d'Ivoire?
Give a very brief answer. -1.29. In the year 2010, what is the difference between the Imports(as % of merchandise exports) of Armenia and Imports(as % of merchandise exports) of Egypt, Arab Rep.?
Ensure brevity in your answer.  -1.13. In the year 2010, what is the difference between the Imports(as % of merchandise exports) of Armenia and Imports(as % of merchandise exports) of Paraguay?
Make the answer very short. 10.49. In the year 2010, what is the difference between the Imports(as % of merchandise exports) of Cote d'Ivoire and Imports(as % of merchandise exports) of Egypt, Arab Rep.?
Provide a succinct answer. 0.17. In the year 2010, what is the difference between the Imports(as % of merchandise exports) in Cote d'Ivoire and Imports(as % of merchandise exports) in Paraguay?
Keep it short and to the point. 11.79. In the year 2010, what is the difference between the Imports(as % of merchandise exports) of Egypt, Arab Rep. and Imports(as % of merchandise exports) of Paraguay?
Your answer should be very brief. 11.62. In the year 2011, what is the difference between the Imports(as % of merchandise exports) of Armenia and Imports(as % of merchandise exports) of Cote d'Ivoire?
Ensure brevity in your answer.  -5.37. In the year 2011, what is the difference between the Imports(as % of merchandise exports) of Armenia and Imports(as % of merchandise exports) of Egypt, Arab Rep.?
Your answer should be very brief. -3.96. In the year 2011, what is the difference between the Imports(as % of merchandise exports) of Armenia and Imports(as % of merchandise exports) of Paraguay?
Offer a very short reply. 12.38. In the year 2011, what is the difference between the Imports(as % of merchandise exports) in Cote d'Ivoire and Imports(as % of merchandise exports) in Egypt, Arab Rep.?
Ensure brevity in your answer.  1.41. In the year 2011, what is the difference between the Imports(as % of merchandise exports) of Cote d'Ivoire and Imports(as % of merchandise exports) of Paraguay?
Provide a succinct answer. 17.75. In the year 2011, what is the difference between the Imports(as % of merchandise exports) of Egypt, Arab Rep. and Imports(as % of merchandise exports) of Paraguay?
Give a very brief answer. 16.34. In the year 2012, what is the difference between the Imports(as % of merchandise exports) in Armenia and Imports(as % of merchandise exports) in Cote d'Ivoire?
Offer a very short reply. -0.97. In the year 2012, what is the difference between the Imports(as % of merchandise exports) in Armenia and Imports(as % of merchandise exports) in Egypt, Arab Rep.?
Your answer should be compact. -3.38. In the year 2012, what is the difference between the Imports(as % of merchandise exports) in Armenia and Imports(as % of merchandise exports) in Paraguay?
Offer a very short reply. 11.09. In the year 2012, what is the difference between the Imports(as % of merchandise exports) in Cote d'Ivoire and Imports(as % of merchandise exports) in Egypt, Arab Rep.?
Provide a short and direct response. -2.4. In the year 2012, what is the difference between the Imports(as % of merchandise exports) of Cote d'Ivoire and Imports(as % of merchandise exports) of Paraguay?
Your response must be concise. 12.07. In the year 2012, what is the difference between the Imports(as % of merchandise exports) in Egypt, Arab Rep. and Imports(as % of merchandise exports) in Paraguay?
Offer a terse response. 14.47. In the year 2013, what is the difference between the Imports(as % of merchandise exports) of Armenia and Imports(as % of merchandise exports) of Cote d'Ivoire?
Provide a short and direct response. 5.74. In the year 2013, what is the difference between the Imports(as % of merchandise exports) in Armenia and Imports(as % of merchandise exports) in Egypt, Arab Rep.?
Your answer should be compact. 2.57. In the year 2013, what is the difference between the Imports(as % of merchandise exports) in Armenia and Imports(as % of merchandise exports) in Paraguay?
Your response must be concise. 12.35. In the year 2013, what is the difference between the Imports(as % of merchandise exports) in Cote d'Ivoire and Imports(as % of merchandise exports) in Egypt, Arab Rep.?
Provide a short and direct response. -3.16. In the year 2013, what is the difference between the Imports(as % of merchandise exports) of Cote d'Ivoire and Imports(as % of merchandise exports) of Paraguay?
Your response must be concise. 6.62. In the year 2013, what is the difference between the Imports(as % of merchandise exports) in Egypt, Arab Rep. and Imports(as % of merchandise exports) in Paraguay?
Offer a very short reply. 9.78. In the year 2014, what is the difference between the Imports(as % of merchandise exports) in Armenia and Imports(as % of merchandise exports) in Cote d'Ivoire?
Keep it short and to the point. 2.67. In the year 2014, what is the difference between the Imports(as % of merchandise exports) in Armenia and Imports(as % of merchandise exports) in Egypt, Arab Rep.?
Provide a short and direct response. -1.59. In the year 2014, what is the difference between the Imports(as % of merchandise exports) of Armenia and Imports(as % of merchandise exports) of Paraguay?
Your answer should be compact. 11.32. In the year 2014, what is the difference between the Imports(as % of merchandise exports) in Cote d'Ivoire and Imports(as % of merchandise exports) in Egypt, Arab Rep.?
Give a very brief answer. -4.26. In the year 2014, what is the difference between the Imports(as % of merchandise exports) of Cote d'Ivoire and Imports(as % of merchandise exports) of Paraguay?
Your answer should be very brief. 8.65. In the year 2014, what is the difference between the Imports(as % of merchandise exports) in Egypt, Arab Rep. and Imports(as % of merchandise exports) in Paraguay?
Provide a short and direct response. 12.91. What is the ratio of the Imports(as % of merchandise exports) of Armenia in 2007 to that in 2008?
Your response must be concise. 0.97. What is the ratio of the Imports(as % of merchandise exports) in Cote d'Ivoire in 2007 to that in 2008?
Make the answer very short. 0.89. What is the ratio of the Imports(as % of merchandise exports) of Egypt, Arab Rep. in 2007 to that in 2008?
Make the answer very short. 1.18. What is the ratio of the Imports(as % of merchandise exports) of Paraguay in 2007 to that in 2008?
Provide a succinct answer. 1.07. What is the ratio of the Imports(as % of merchandise exports) of Armenia in 2007 to that in 2009?
Provide a succinct answer. 0.94. What is the ratio of the Imports(as % of merchandise exports) of Cote d'Ivoire in 2007 to that in 2009?
Provide a short and direct response. 0.75. What is the ratio of the Imports(as % of merchandise exports) of Egypt, Arab Rep. in 2007 to that in 2009?
Offer a very short reply. 1.18. What is the ratio of the Imports(as % of merchandise exports) in Paraguay in 2007 to that in 2009?
Your answer should be compact. 0.86. What is the ratio of the Imports(as % of merchandise exports) of Armenia in 2007 to that in 2010?
Make the answer very short. 1.01. What is the ratio of the Imports(as % of merchandise exports) in Cote d'Ivoire in 2007 to that in 2010?
Offer a terse response. 0.9. What is the ratio of the Imports(as % of merchandise exports) in Egypt, Arab Rep. in 2007 to that in 2010?
Make the answer very short. 1.07. What is the ratio of the Imports(as % of merchandise exports) of Paraguay in 2007 to that in 2010?
Provide a succinct answer. 0.94. What is the ratio of the Imports(as % of merchandise exports) in Armenia in 2007 to that in 2011?
Your answer should be very brief. 0.92. What is the ratio of the Imports(as % of merchandise exports) of Cote d'Ivoire in 2007 to that in 2011?
Your response must be concise. 0.69. What is the ratio of the Imports(as % of merchandise exports) in Egypt, Arab Rep. in 2007 to that in 2011?
Your response must be concise. 0.86. What is the ratio of the Imports(as % of merchandise exports) in Paraguay in 2007 to that in 2011?
Ensure brevity in your answer.  0.96. What is the ratio of the Imports(as % of merchandise exports) of Armenia in 2007 to that in 2012?
Give a very brief answer. 0.95. What is the ratio of the Imports(as % of merchandise exports) of Cote d'Ivoire in 2007 to that in 2012?
Offer a very short reply. 0.87. What is the ratio of the Imports(as % of merchandise exports) in Egypt, Arab Rep. in 2007 to that in 2012?
Provide a succinct answer. 0.91. What is the ratio of the Imports(as % of merchandise exports) of Paraguay in 2007 to that in 2012?
Offer a very short reply. 0.89. What is the ratio of the Imports(as % of merchandise exports) in Armenia in 2007 to that in 2013?
Your answer should be compact. 0.89. What is the ratio of the Imports(as % of merchandise exports) in Cote d'Ivoire in 2007 to that in 2013?
Your response must be concise. 1.19. What is the ratio of the Imports(as % of merchandise exports) in Egypt, Arab Rep. in 2007 to that in 2013?
Provide a succinct answer. 1.15. What is the ratio of the Imports(as % of merchandise exports) of Paraguay in 2007 to that in 2013?
Make the answer very short. 0.88. What is the ratio of the Imports(as % of merchandise exports) in Armenia in 2007 to that in 2014?
Provide a short and direct response. 0.93. What is the ratio of the Imports(as % of merchandise exports) in Cote d'Ivoire in 2007 to that in 2014?
Provide a succinct answer. 1.03. What is the ratio of the Imports(as % of merchandise exports) of Egypt, Arab Rep. in 2007 to that in 2014?
Ensure brevity in your answer.  0.96. What is the ratio of the Imports(as % of merchandise exports) of Paraguay in 2007 to that in 2014?
Provide a short and direct response. 0.86. What is the ratio of the Imports(as % of merchandise exports) of Armenia in 2008 to that in 2009?
Give a very brief answer. 0.97. What is the ratio of the Imports(as % of merchandise exports) in Cote d'Ivoire in 2008 to that in 2009?
Provide a short and direct response. 0.85. What is the ratio of the Imports(as % of merchandise exports) of Egypt, Arab Rep. in 2008 to that in 2009?
Ensure brevity in your answer.  1. What is the ratio of the Imports(as % of merchandise exports) of Paraguay in 2008 to that in 2009?
Your answer should be very brief. 0.8. What is the ratio of the Imports(as % of merchandise exports) in Armenia in 2008 to that in 2010?
Your response must be concise. 1.04. What is the ratio of the Imports(as % of merchandise exports) in Cote d'Ivoire in 2008 to that in 2010?
Make the answer very short. 1.02. What is the ratio of the Imports(as % of merchandise exports) of Egypt, Arab Rep. in 2008 to that in 2010?
Your response must be concise. 0.9. What is the ratio of the Imports(as % of merchandise exports) of Paraguay in 2008 to that in 2010?
Ensure brevity in your answer.  0.89. What is the ratio of the Imports(as % of merchandise exports) of Armenia in 2008 to that in 2011?
Offer a very short reply. 0.94. What is the ratio of the Imports(as % of merchandise exports) of Cote d'Ivoire in 2008 to that in 2011?
Make the answer very short. 0.78. What is the ratio of the Imports(as % of merchandise exports) of Egypt, Arab Rep. in 2008 to that in 2011?
Keep it short and to the point. 0.72. What is the ratio of the Imports(as % of merchandise exports) of Paraguay in 2008 to that in 2011?
Your answer should be compact. 0.9. What is the ratio of the Imports(as % of merchandise exports) in Armenia in 2008 to that in 2012?
Provide a short and direct response. 0.98. What is the ratio of the Imports(as % of merchandise exports) of Egypt, Arab Rep. in 2008 to that in 2012?
Provide a short and direct response. 0.77. What is the ratio of the Imports(as % of merchandise exports) of Paraguay in 2008 to that in 2012?
Your answer should be very brief. 0.83. What is the ratio of the Imports(as % of merchandise exports) in Armenia in 2008 to that in 2013?
Give a very brief answer. 0.92. What is the ratio of the Imports(as % of merchandise exports) of Cote d'Ivoire in 2008 to that in 2013?
Provide a succinct answer. 1.34. What is the ratio of the Imports(as % of merchandise exports) in Egypt, Arab Rep. in 2008 to that in 2013?
Offer a very short reply. 0.97. What is the ratio of the Imports(as % of merchandise exports) of Paraguay in 2008 to that in 2013?
Provide a succinct answer. 0.83. What is the ratio of the Imports(as % of merchandise exports) in Armenia in 2008 to that in 2014?
Ensure brevity in your answer.  0.96. What is the ratio of the Imports(as % of merchandise exports) in Cote d'Ivoire in 2008 to that in 2014?
Offer a terse response. 1.16. What is the ratio of the Imports(as % of merchandise exports) in Egypt, Arab Rep. in 2008 to that in 2014?
Your response must be concise. 0.81. What is the ratio of the Imports(as % of merchandise exports) in Paraguay in 2008 to that in 2014?
Give a very brief answer. 0.81. What is the ratio of the Imports(as % of merchandise exports) of Armenia in 2009 to that in 2010?
Your answer should be compact. 1.08. What is the ratio of the Imports(as % of merchandise exports) of Cote d'Ivoire in 2009 to that in 2010?
Offer a very short reply. 1.2. What is the ratio of the Imports(as % of merchandise exports) of Egypt, Arab Rep. in 2009 to that in 2010?
Your answer should be very brief. 0.9. What is the ratio of the Imports(as % of merchandise exports) in Paraguay in 2009 to that in 2010?
Your answer should be compact. 1.1. What is the ratio of the Imports(as % of merchandise exports) of Armenia in 2009 to that in 2011?
Give a very brief answer. 0.98. What is the ratio of the Imports(as % of merchandise exports) of Cote d'Ivoire in 2009 to that in 2011?
Your answer should be compact. 0.92. What is the ratio of the Imports(as % of merchandise exports) in Egypt, Arab Rep. in 2009 to that in 2011?
Your answer should be compact. 0.72. What is the ratio of the Imports(as % of merchandise exports) in Paraguay in 2009 to that in 2011?
Your answer should be compact. 1.12. What is the ratio of the Imports(as % of merchandise exports) in Armenia in 2009 to that in 2012?
Provide a short and direct response. 1.01. What is the ratio of the Imports(as % of merchandise exports) in Cote d'Ivoire in 2009 to that in 2012?
Give a very brief answer. 1.16. What is the ratio of the Imports(as % of merchandise exports) in Egypt, Arab Rep. in 2009 to that in 2012?
Provide a succinct answer. 0.77. What is the ratio of the Imports(as % of merchandise exports) in Paraguay in 2009 to that in 2012?
Your answer should be very brief. 1.04. What is the ratio of the Imports(as % of merchandise exports) of Armenia in 2009 to that in 2013?
Offer a terse response. 0.95. What is the ratio of the Imports(as % of merchandise exports) in Cote d'Ivoire in 2009 to that in 2013?
Your answer should be very brief. 1.59. What is the ratio of the Imports(as % of merchandise exports) in Paraguay in 2009 to that in 2013?
Give a very brief answer. 1.03. What is the ratio of the Imports(as % of merchandise exports) in Armenia in 2009 to that in 2014?
Your answer should be very brief. 0.99. What is the ratio of the Imports(as % of merchandise exports) of Cote d'Ivoire in 2009 to that in 2014?
Give a very brief answer. 1.38. What is the ratio of the Imports(as % of merchandise exports) of Egypt, Arab Rep. in 2009 to that in 2014?
Your answer should be very brief. 0.81. What is the ratio of the Imports(as % of merchandise exports) in Armenia in 2010 to that in 2011?
Your answer should be compact. 0.91. What is the ratio of the Imports(as % of merchandise exports) in Cote d'Ivoire in 2010 to that in 2011?
Your answer should be compact. 0.77. What is the ratio of the Imports(as % of merchandise exports) of Egypt, Arab Rep. in 2010 to that in 2011?
Your response must be concise. 0.8. What is the ratio of the Imports(as % of merchandise exports) of Paraguay in 2010 to that in 2011?
Provide a short and direct response. 1.01. What is the ratio of the Imports(as % of merchandise exports) in Armenia in 2010 to that in 2012?
Keep it short and to the point. 0.94. What is the ratio of the Imports(as % of merchandise exports) in Cote d'Ivoire in 2010 to that in 2012?
Give a very brief answer. 0.96. What is the ratio of the Imports(as % of merchandise exports) of Egypt, Arab Rep. in 2010 to that in 2012?
Give a very brief answer. 0.85. What is the ratio of the Imports(as % of merchandise exports) of Paraguay in 2010 to that in 2012?
Your answer should be compact. 0.94. What is the ratio of the Imports(as % of merchandise exports) of Armenia in 2010 to that in 2013?
Your answer should be compact. 0.88. What is the ratio of the Imports(as % of merchandise exports) of Cote d'Ivoire in 2010 to that in 2013?
Give a very brief answer. 1.32. What is the ratio of the Imports(as % of merchandise exports) in Egypt, Arab Rep. in 2010 to that in 2013?
Provide a succinct answer. 1.08. What is the ratio of the Imports(as % of merchandise exports) of Paraguay in 2010 to that in 2013?
Ensure brevity in your answer.  0.94. What is the ratio of the Imports(as % of merchandise exports) in Armenia in 2010 to that in 2014?
Make the answer very short. 0.92. What is the ratio of the Imports(as % of merchandise exports) of Cote d'Ivoire in 2010 to that in 2014?
Your response must be concise. 1.14. What is the ratio of the Imports(as % of merchandise exports) of Egypt, Arab Rep. in 2010 to that in 2014?
Offer a terse response. 0.9. What is the ratio of the Imports(as % of merchandise exports) of Paraguay in 2010 to that in 2014?
Your answer should be very brief. 0.91. What is the ratio of the Imports(as % of merchandise exports) in Armenia in 2011 to that in 2012?
Your response must be concise. 1.04. What is the ratio of the Imports(as % of merchandise exports) of Cote d'Ivoire in 2011 to that in 2012?
Keep it short and to the point. 1.26. What is the ratio of the Imports(as % of merchandise exports) in Egypt, Arab Rep. in 2011 to that in 2012?
Offer a terse response. 1.06. What is the ratio of the Imports(as % of merchandise exports) in Paraguay in 2011 to that in 2012?
Ensure brevity in your answer.  0.93. What is the ratio of the Imports(as % of merchandise exports) of Armenia in 2011 to that in 2013?
Your answer should be compact. 0.97. What is the ratio of the Imports(as % of merchandise exports) in Cote d'Ivoire in 2011 to that in 2013?
Your response must be concise. 1.72. What is the ratio of the Imports(as % of merchandise exports) in Egypt, Arab Rep. in 2011 to that in 2013?
Make the answer very short. 1.34. What is the ratio of the Imports(as % of merchandise exports) in Paraguay in 2011 to that in 2013?
Provide a short and direct response. 0.93. What is the ratio of the Imports(as % of merchandise exports) of Armenia in 2011 to that in 2014?
Provide a succinct answer. 1.01. What is the ratio of the Imports(as % of merchandise exports) of Cote d'Ivoire in 2011 to that in 2014?
Offer a terse response. 1.49. What is the ratio of the Imports(as % of merchandise exports) in Egypt, Arab Rep. in 2011 to that in 2014?
Give a very brief answer. 1.12. What is the ratio of the Imports(as % of merchandise exports) in Paraguay in 2011 to that in 2014?
Offer a very short reply. 0.9. What is the ratio of the Imports(as % of merchandise exports) of Armenia in 2012 to that in 2013?
Your answer should be compact. 0.94. What is the ratio of the Imports(as % of merchandise exports) in Cote d'Ivoire in 2012 to that in 2013?
Provide a succinct answer. 1.37. What is the ratio of the Imports(as % of merchandise exports) of Egypt, Arab Rep. in 2012 to that in 2013?
Your answer should be compact. 1.26. What is the ratio of the Imports(as % of merchandise exports) in Armenia in 2012 to that in 2014?
Your answer should be very brief. 0.98. What is the ratio of the Imports(as % of merchandise exports) in Cote d'Ivoire in 2012 to that in 2014?
Give a very brief answer. 1.19. What is the ratio of the Imports(as % of merchandise exports) of Egypt, Arab Rep. in 2012 to that in 2014?
Make the answer very short. 1.06. What is the ratio of the Imports(as % of merchandise exports) of Paraguay in 2012 to that in 2014?
Offer a very short reply. 0.97. What is the ratio of the Imports(as % of merchandise exports) of Armenia in 2013 to that in 2014?
Offer a terse response. 1.04. What is the ratio of the Imports(as % of merchandise exports) of Cote d'Ivoire in 2013 to that in 2014?
Make the answer very short. 0.87. What is the ratio of the Imports(as % of merchandise exports) in Egypt, Arab Rep. in 2013 to that in 2014?
Your response must be concise. 0.84. What is the ratio of the Imports(as % of merchandise exports) of Paraguay in 2013 to that in 2014?
Give a very brief answer. 0.97. What is the difference between the highest and the second highest Imports(as % of merchandise exports) in Armenia?
Provide a succinct answer. 0.56. What is the difference between the highest and the second highest Imports(as % of merchandise exports) in Cote d'Ivoire?
Ensure brevity in your answer.  1.95. What is the difference between the highest and the second highest Imports(as % of merchandise exports) in Egypt, Arab Rep.?
Offer a terse response. 1.3. What is the difference between the highest and the second highest Imports(as % of merchandise exports) of Paraguay?
Your answer should be compact. 0.04. What is the difference between the highest and the lowest Imports(as % of merchandise exports) in Armenia?
Make the answer very short. 2.36. What is the difference between the highest and the lowest Imports(as % of merchandise exports) in Cote d'Ivoire?
Give a very brief answer. 10.55. What is the difference between the highest and the lowest Imports(as % of merchandise exports) of Egypt, Arab Rep.?
Offer a terse response. 6.55. What is the difference between the highest and the lowest Imports(as % of merchandise exports) in Paraguay?
Make the answer very short. 1.63. 